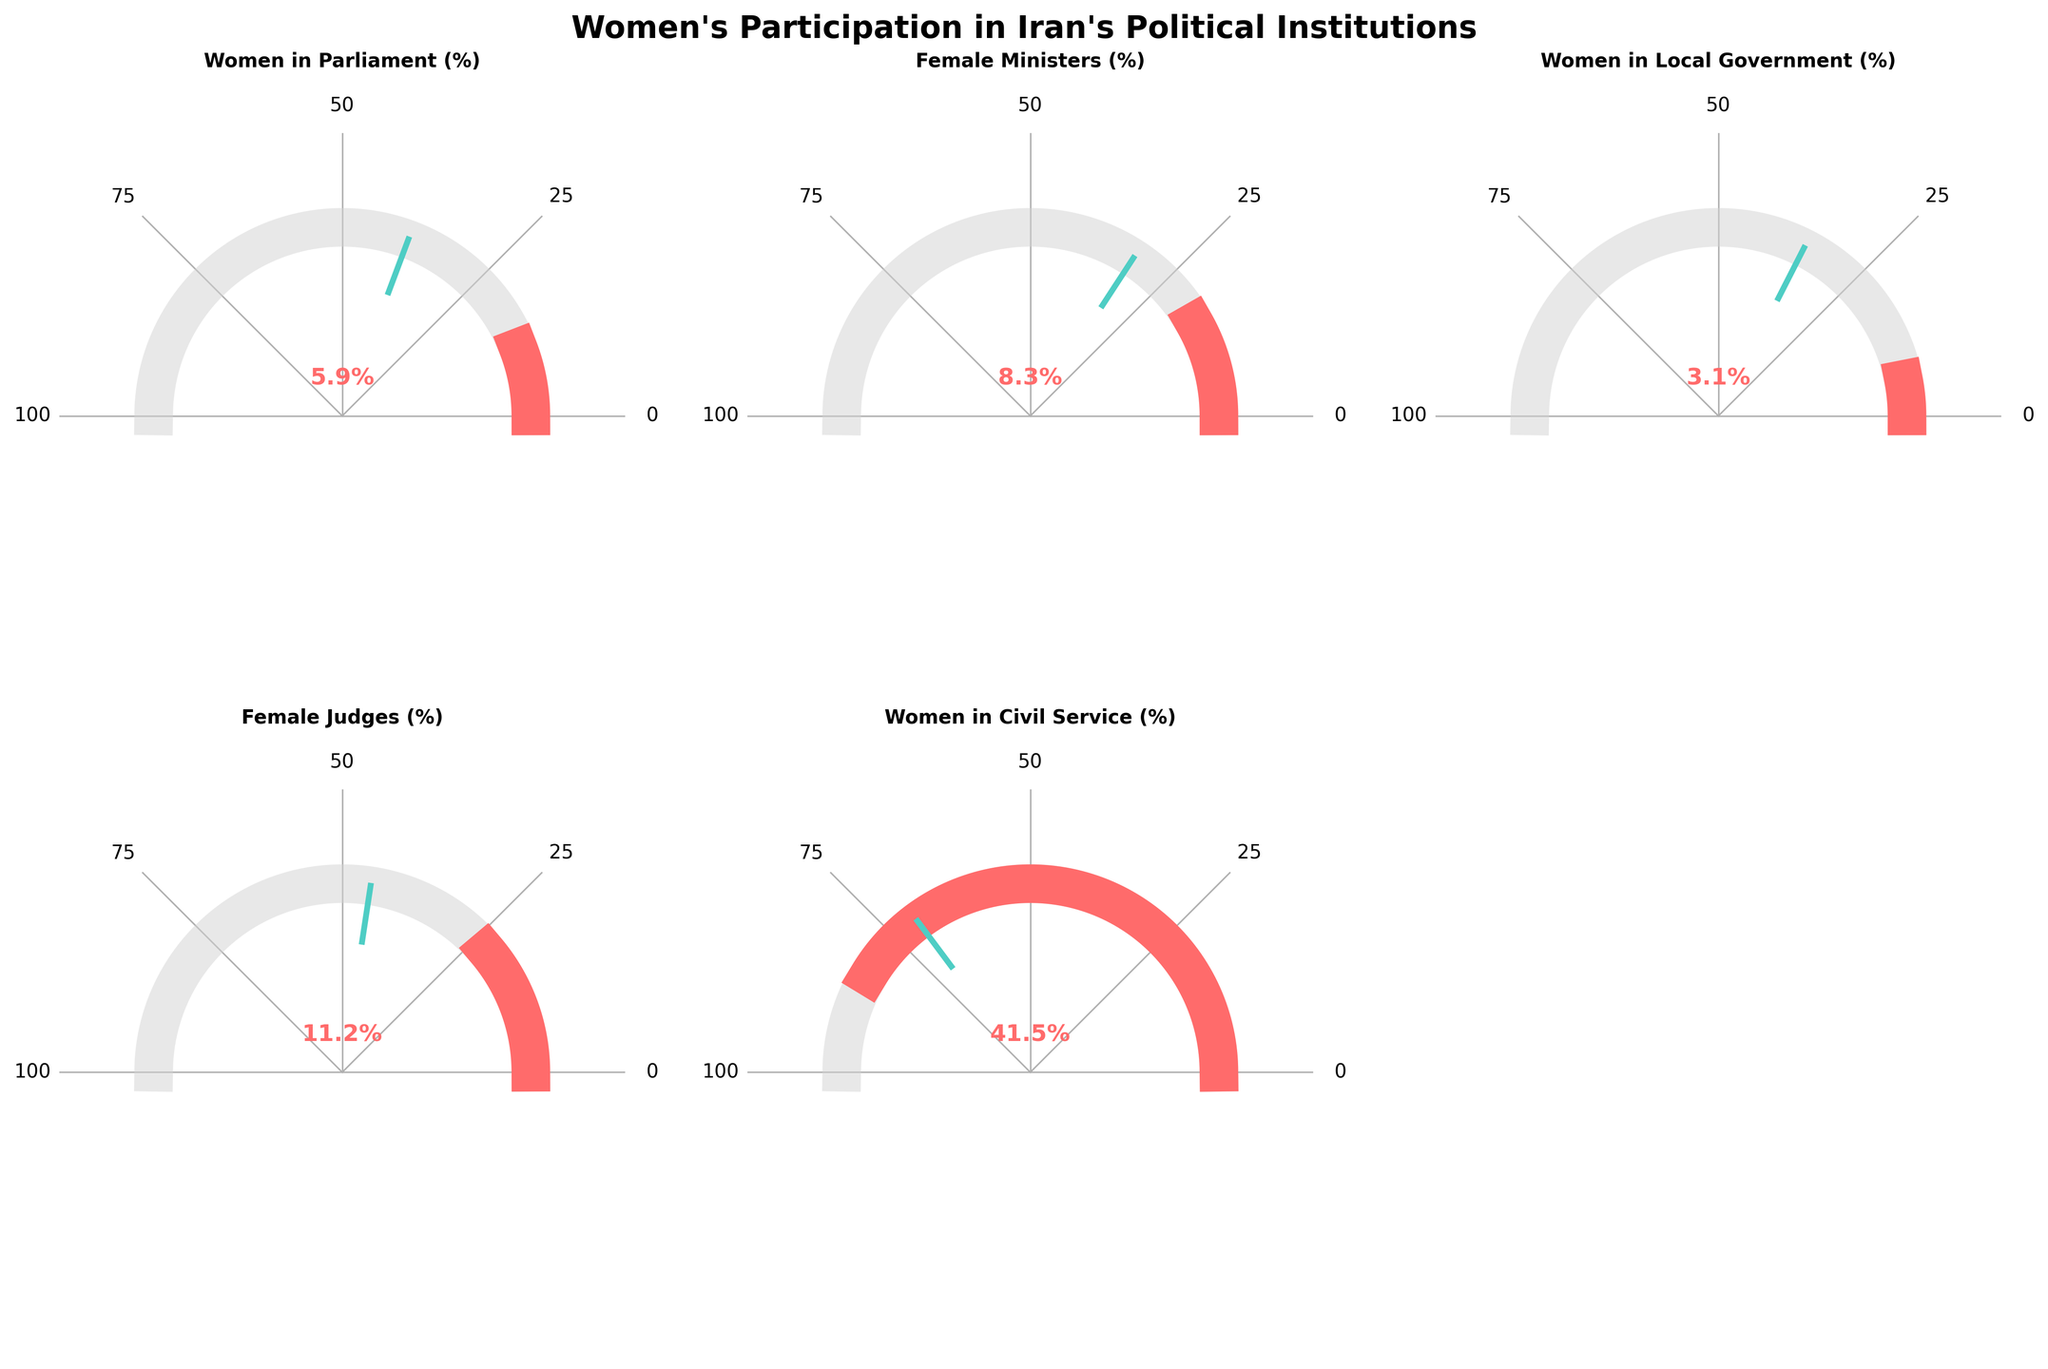Which category has the highest percentage of women's participation? The category with the greatest percentage is shown by the gauge with the lengthiest red bar. "Women in Civil Service" has the highest percentage at 41.5%.
Answer: Women in Civil Service Which category has the lowest percentage of women's participation? The category with the smallest percentage is indicated by the gauge with the smallest red bar. "Women in Local Government" has the lowest percentage at 3.1%.
Answer: Women in Local Government How does the percentage of women in parliament in Iran compare to the regional average? The value for Iran's "Women in Parliament" is 5.9%, while the regional average is 19.3%. Therefore, Iran's percentage is significantly lower than the regional average.
Answer: Lower Are there any categories where Iran has a higher percentage than the regional average? By comparing the values and regional averages, only "Women in Civil Service" in Iran (41.5%) surpasses the regional average (35.2%).
Answer: Yes What is the percentage difference between the regional average and Iran's value for female ministers? To find this difference, subtract Iran's percentage (8.3%) from the regional average (15.8%). The difference is 15.8% - 8.3% = 7.5%.
Answer: 7.5% What is the average participation rate of women across all categories in Iran? To calculate the average, sum all the percentages in Iran (5.9% + 8.3% + 3.1% + 11.2% + 41.5%) and divide by the number of categories (5). The average is (5.9 + 8.3 + 3.1 + 11.2 + 41.5) / 5 = 69.9 / 5 = 13.98%.
Answer: 13.98% Which category shows the greatest disparity between Iran's percentage and the regional average? By comparing all differences, "Female Judges" shows the greatest disparity: 22.6% (regional average) - 11.2% (Iran) = 11.4%.
Answer: Female Judges 